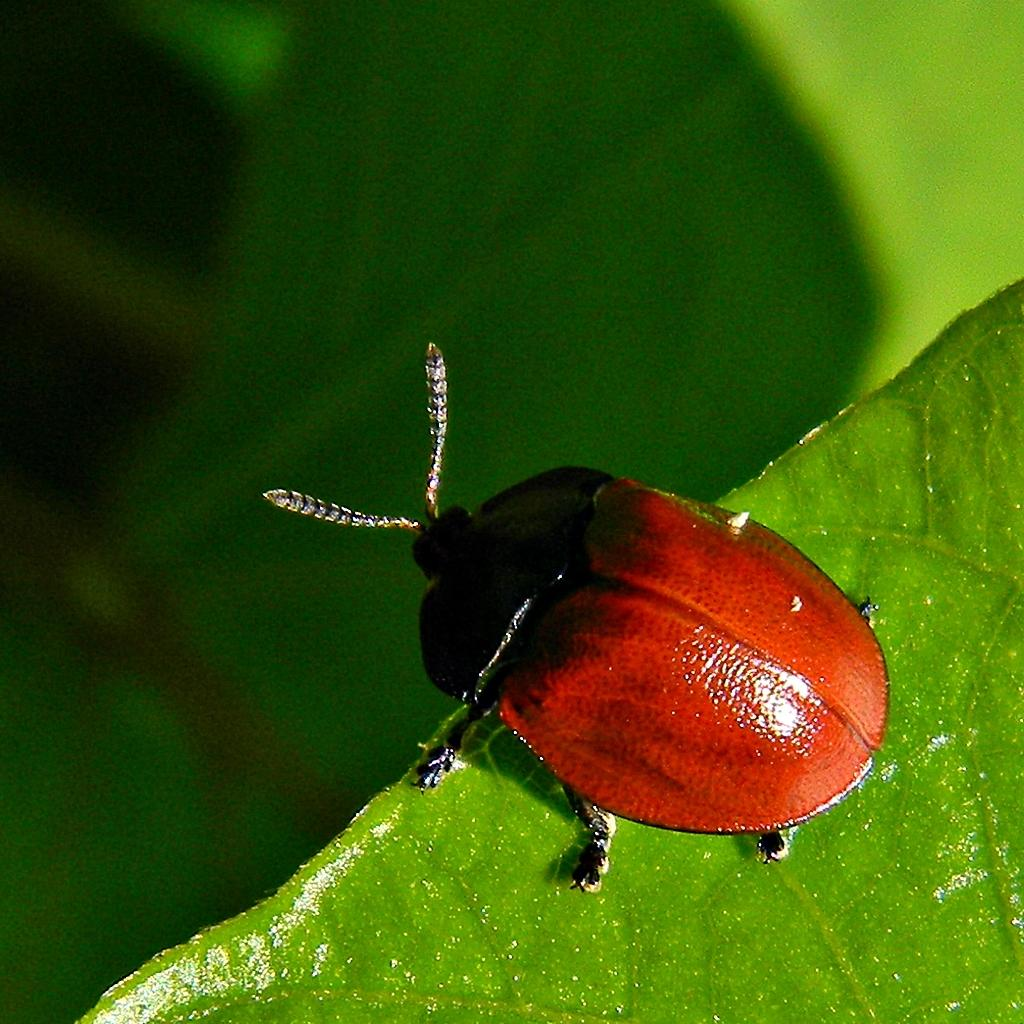What is present in the image? There is an insect in the image. Where is the insect located? The insect is on a leaf. How many frogs are sitting on the insect's toe in the image? There are no frogs or toes present in the image; it only features an insect on a leaf. 